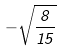<formula> <loc_0><loc_0><loc_500><loc_500>- \sqrt { \frac { 8 } { 1 5 } }</formula> 